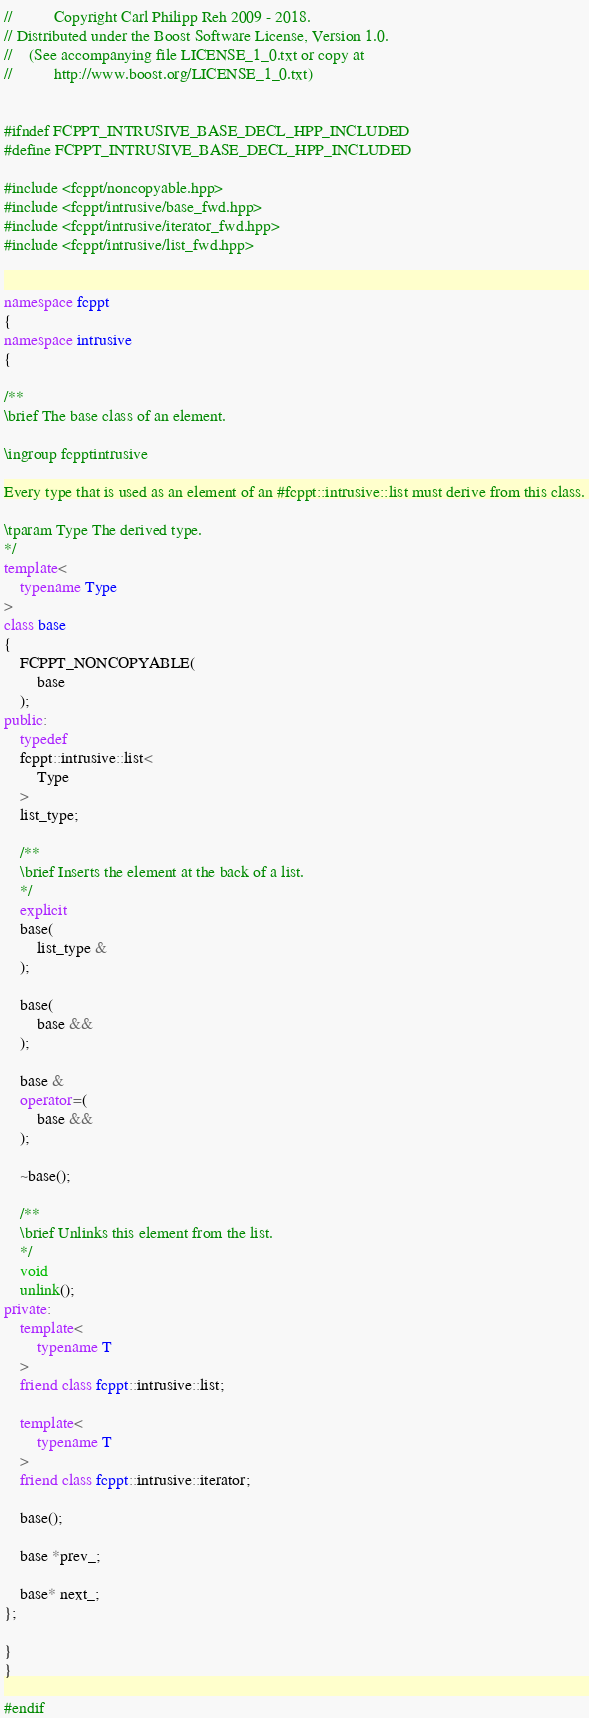Convert code to text. <code><loc_0><loc_0><loc_500><loc_500><_C++_>//          Copyright Carl Philipp Reh 2009 - 2018.
// Distributed under the Boost Software License, Version 1.0.
//    (See accompanying file LICENSE_1_0.txt or copy at
//          http://www.boost.org/LICENSE_1_0.txt)


#ifndef FCPPT_INTRUSIVE_BASE_DECL_HPP_INCLUDED
#define FCPPT_INTRUSIVE_BASE_DECL_HPP_INCLUDED

#include <fcppt/noncopyable.hpp>
#include <fcppt/intrusive/base_fwd.hpp>
#include <fcppt/intrusive/iterator_fwd.hpp>
#include <fcppt/intrusive/list_fwd.hpp>


namespace fcppt
{
namespace intrusive
{

/**
\brief The base class of an element.

\ingroup fcpptintrusive

Every type that is used as an element of an #fcppt::intrusive::list must derive from this class.

\tparam Type The derived type.
*/
template<
	typename Type
>
class base
{
	FCPPT_NONCOPYABLE(
		base
	);
public:
	typedef
	fcppt::intrusive::list<
		Type
	>
	list_type;

	/**
	\brief Inserts the element at the back of a list.
	*/
	explicit
	base(
		list_type &
	);

	base(
		base &&
	);

	base &
	operator=(
		base &&
	);

	~base();

	/**
	\brief Unlinks this element from the list.
	*/
	void
	unlink();
private:
	template<
		typename T
	>
	friend class fcppt::intrusive::list;

	template<
		typename T
	>
	friend class fcppt::intrusive::iterator;

	base();

	base *prev_;

	base* next_;
};

}
}

#endif
</code> 